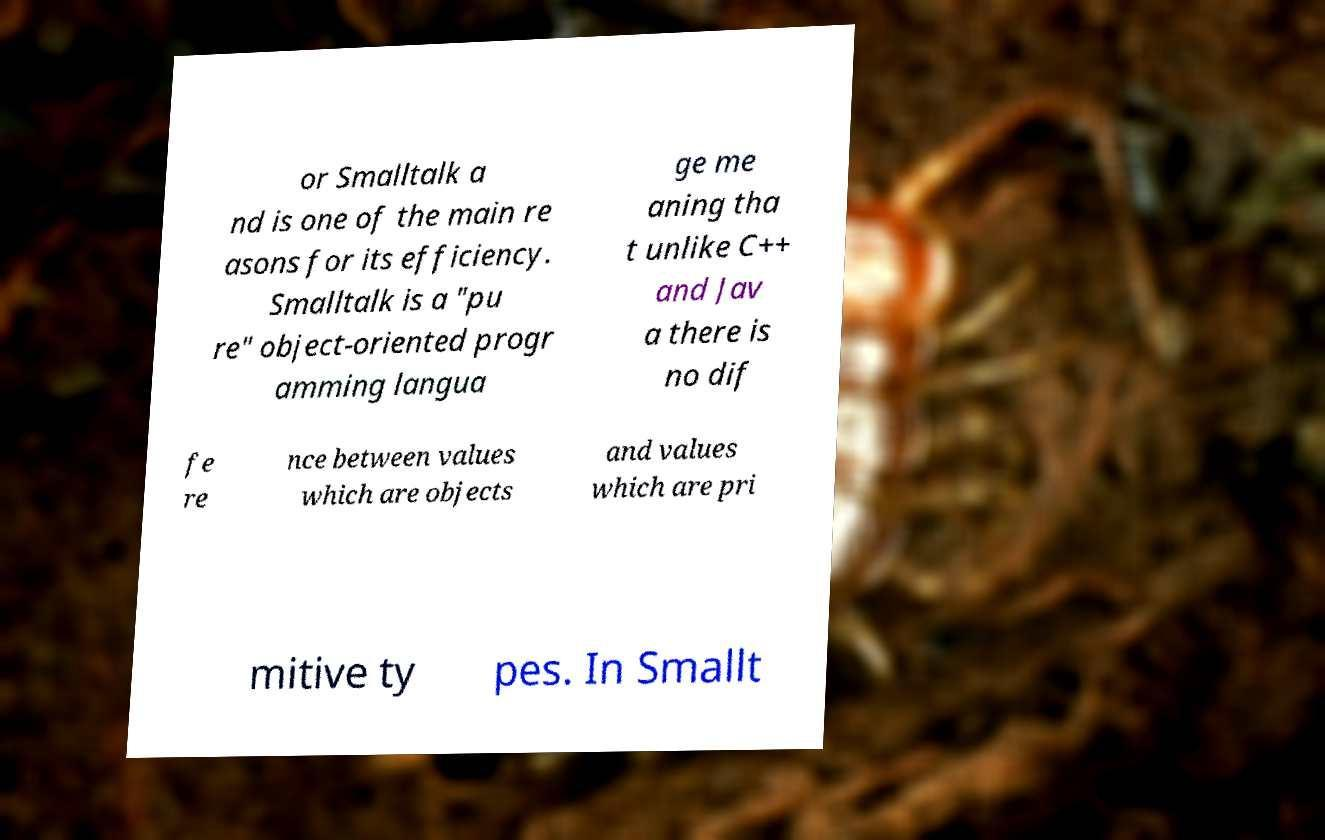For documentation purposes, I need the text within this image transcribed. Could you provide that? or Smalltalk a nd is one of the main re asons for its efficiency. Smalltalk is a "pu re" object-oriented progr amming langua ge me aning tha t unlike C++ and Jav a there is no dif fe re nce between values which are objects and values which are pri mitive ty pes. In Smallt 